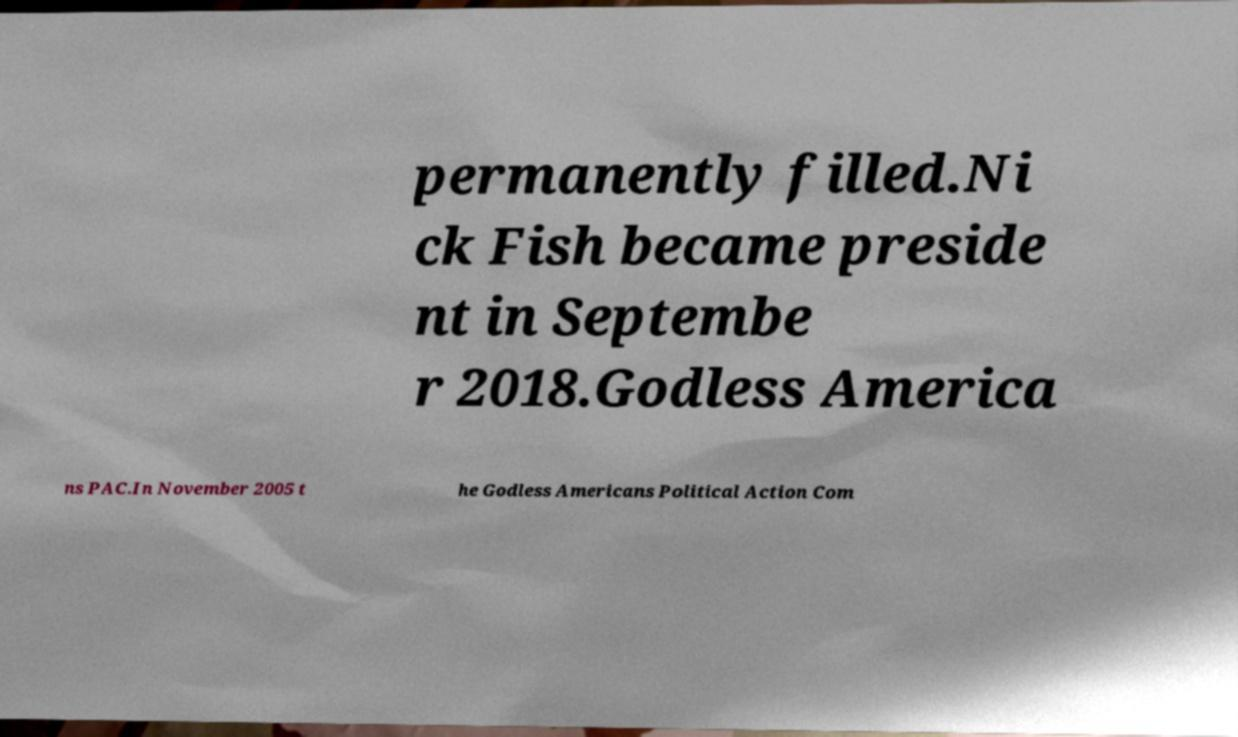Can you accurately transcribe the text from the provided image for me? permanently filled.Ni ck Fish became preside nt in Septembe r 2018.Godless America ns PAC.In November 2005 t he Godless Americans Political Action Com 